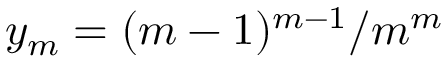Convert formula to latex. <formula><loc_0><loc_0><loc_500><loc_500>y _ { m } = ( m - 1 ) ^ { m - 1 } / m ^ { m }</formula> 